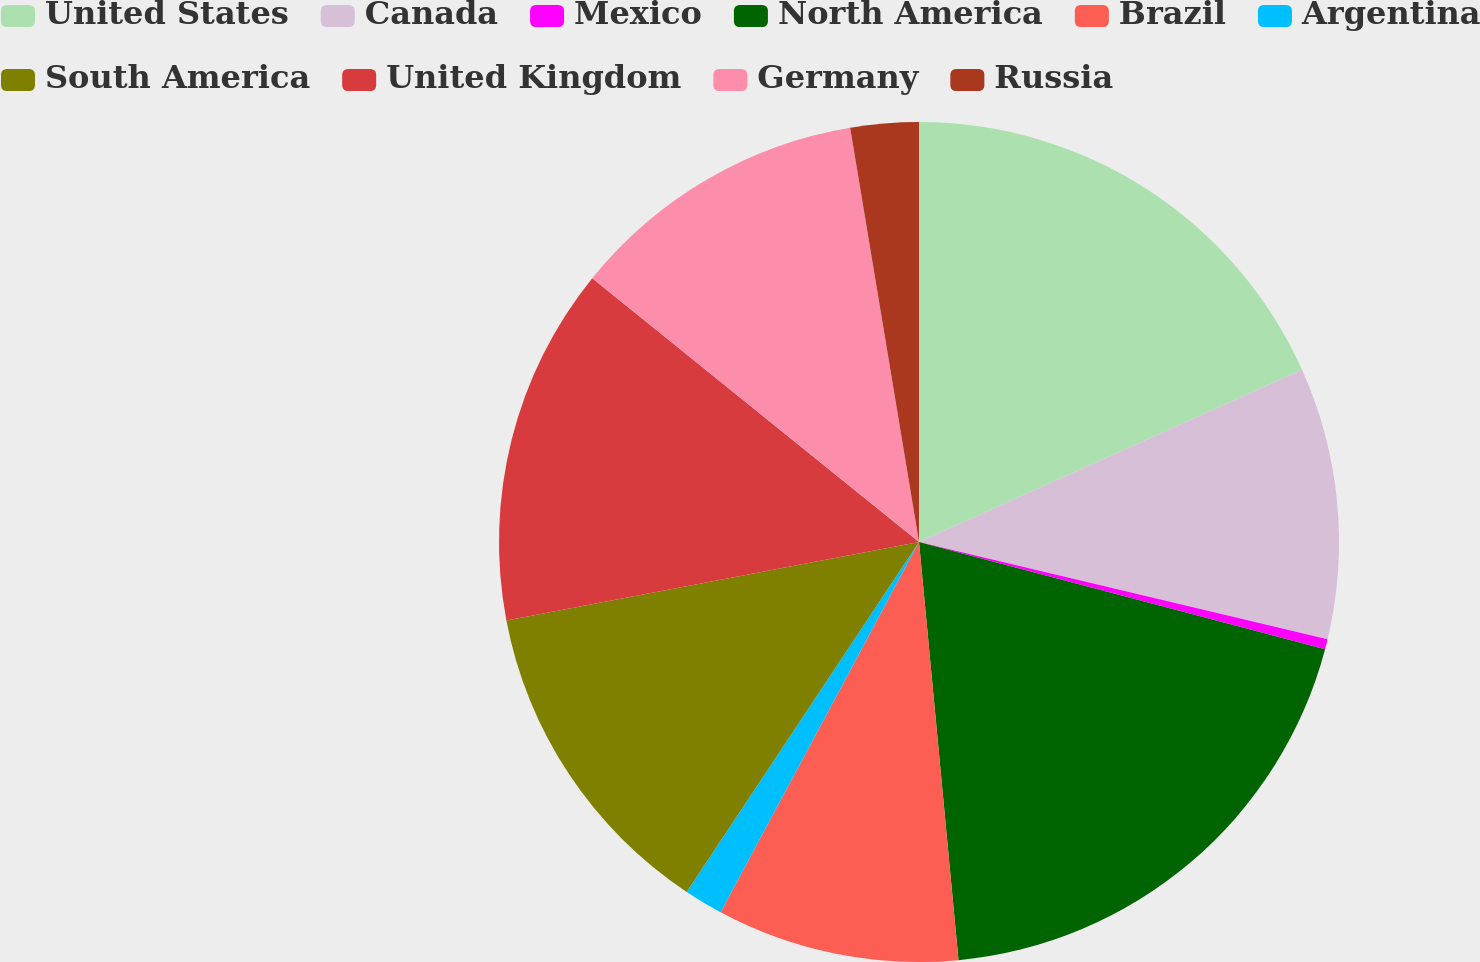<chart> <loc_0><loc_0><loc_500><loc_500><pie_chart><fcel>United States<fcel>Canada<fcel>Mexico<fcel>North America<fcel>Brazil<fcel>Argentina<fcel>South America<fcel>United Kingdom<fcel>Germany<fcel>Russia<nl><fcel>18.27%<fcel>10.45%<fcel>0.39%<fcel>19.39%<fcel>9.33%<fcel>1.5%<fcel>12.68%<fcel>13.8%<fcel>11.57%<fcel>2.62%<nl></chart> 